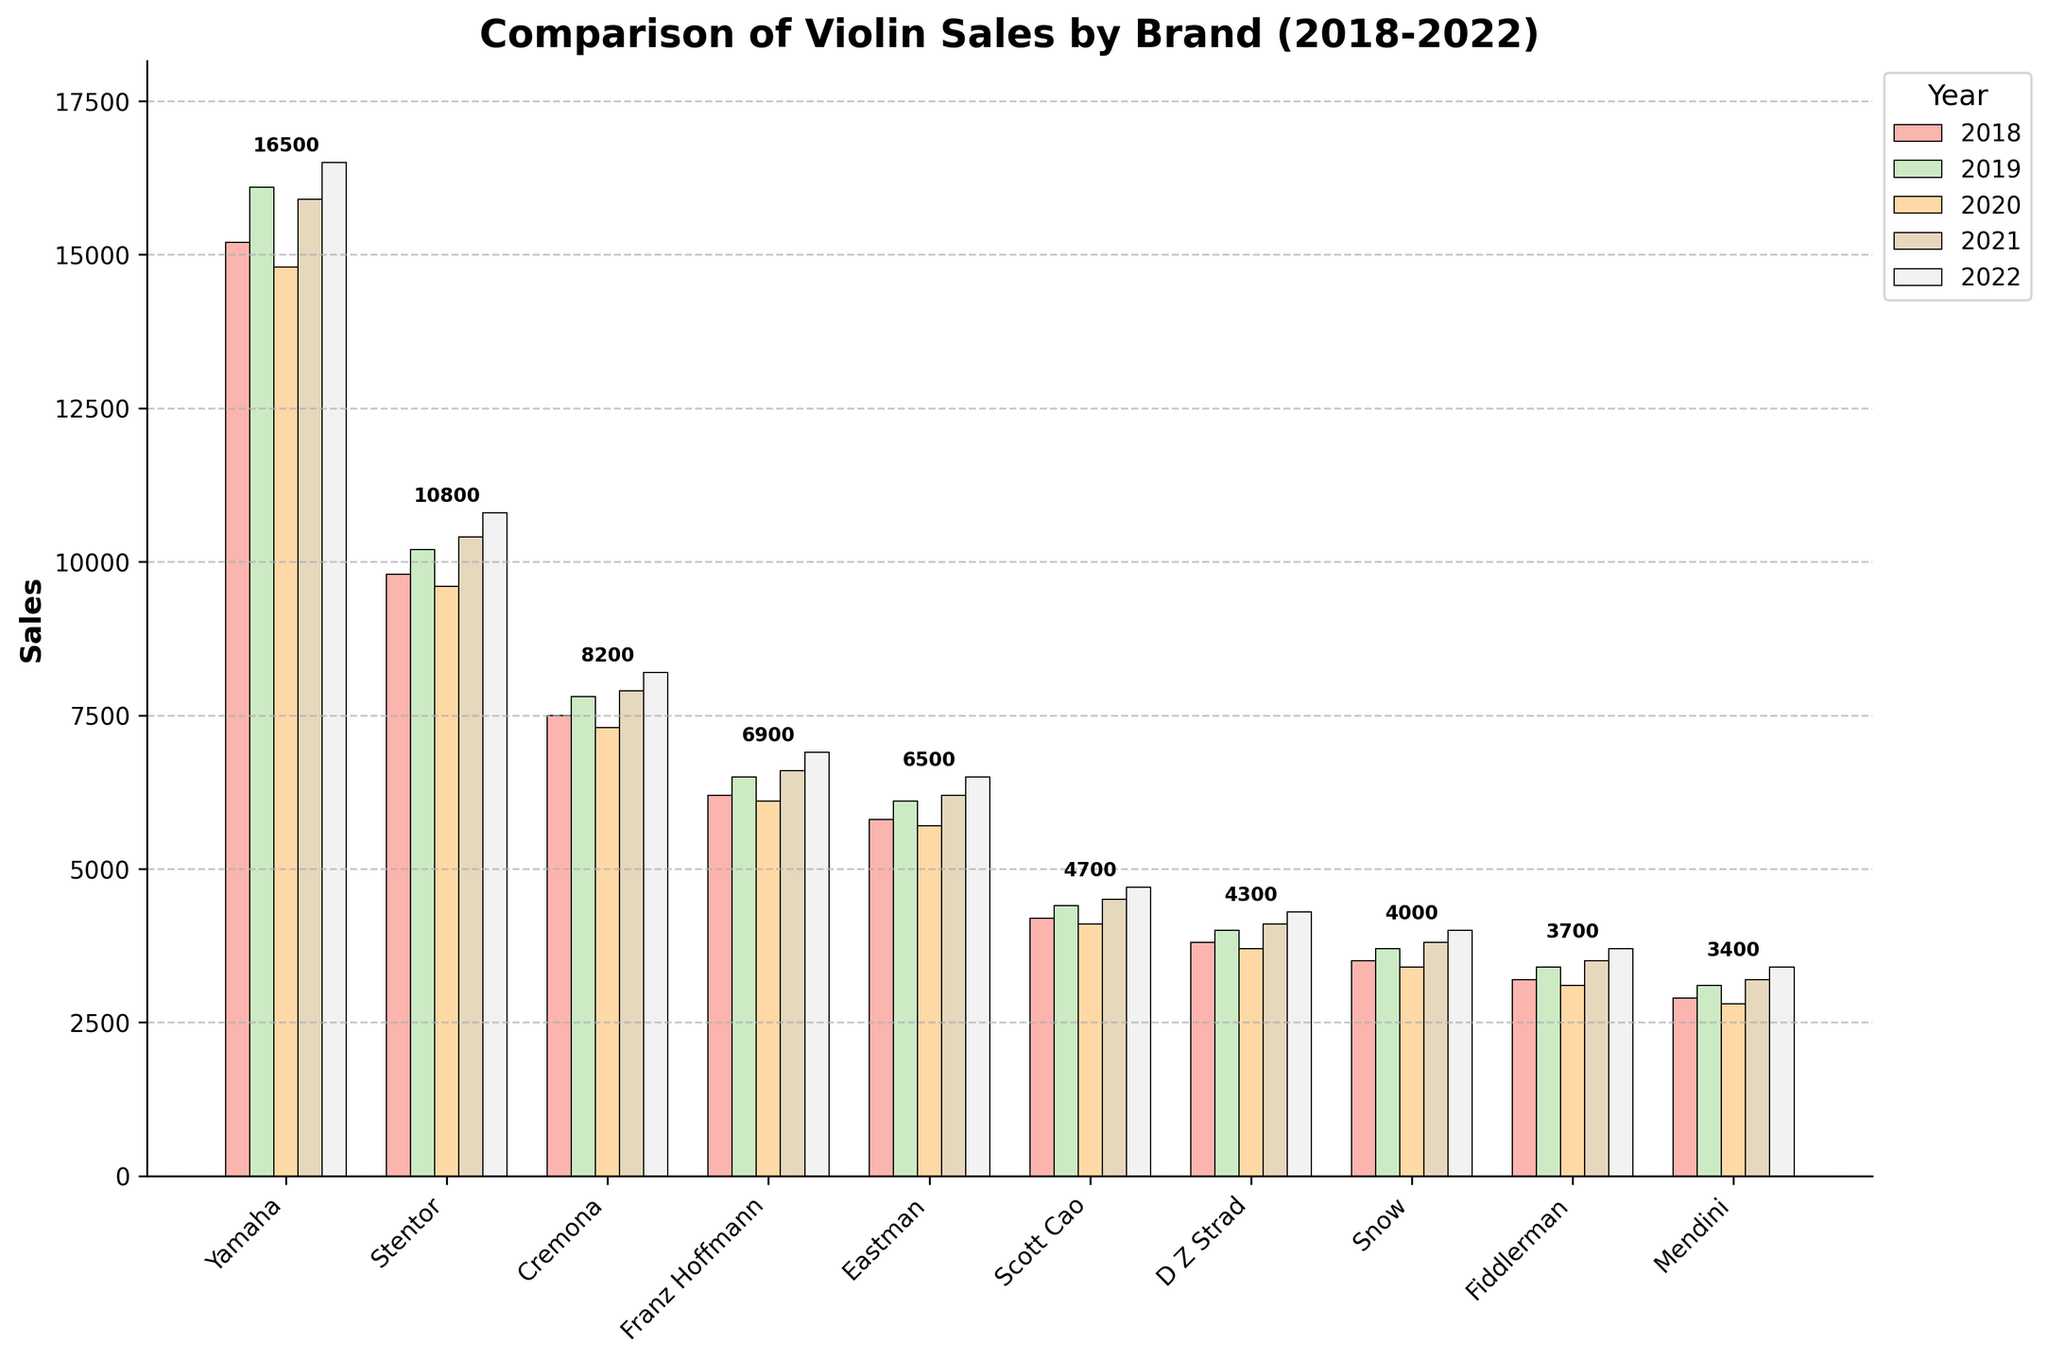what was the highest sales figure for Yamaha? The highest sales figure for Yamaha can be identified by looking at the tallest bar for Yamaha across all years. Based on the bar heights, Yamaha had the highest sales in 2022.
Answer: 16500 In which year did Stentor achieve its highest sales? By comparing the heights of the bars representing Stentor for each year, it can be observed that the bar corresponding to the year 2022 is the tallest.
Answer: 2022 Which brand had the lowest sales in 2018 and what was the value? By looking at the bars for 2018, the shortest bar represents the brand with the lowest sales. The shortest bar in 2018 is for Mendini.
Answer: Mendini, 2900 How did Eastman's sales in 2020 compare to its sales in 2019? To compare Eastman's sales in 2020 and 2019, observe the heights of the bars for these two years. The bar for 2020 is shorter than that for 2019.
Answer: Less in 2020 What is the average sales figure for Scott Cao over the 5 year period? To find the average sales figure for Scott Cao, add the sales values for each year and divide by the number of years: (4200 + 4400 + 4100 + 4500 + 4700) / 5. This gives 21900 / 5 = 4380.
Answer: 4380 Which year shows the highest overall sales for the listed brands? Summing the heights of all bars for each year, the highest sum represents the year with the highest overall sales. 2022 has the highest individual bars added together.
Answer: 2022 What trend can be observed among all brands in the year 2022 compared to 2018? By comparing the overall heights of bars for 2018 and 2022, it can be observed that, in general, the bars for 2022 are taller, indicating an increase in sales for most brands.
Answer: Increasing trend Which brand had consistent growth in sales every year from 2018 to 2022? To determine which brand had consistent growth, observe the trend of the bars from 2018 to 2022. Yamaha shows a steady increase every year.
Answer: Yamaha Which brands sold more violins in 2021 than in 2020? By comparing the heights of the bars for 2021 and 2020, it can be seen that the brands that had taller bars in 2021 than 2020 are: Yamaha, Stentor, Cremona, Franz Hoffmann, Eastman, Scott Cao, D Z Strad, Snow, and Fiddlerman.
Answer: Most brands except Mendini What is the total sales figure for D Z Strad for the entire 5 year period? Summing the sales figures for D Z Strad for each year: 3800 + 4000 + 3700 + 4100 + 4300 = 19900.
Answer: 19900 